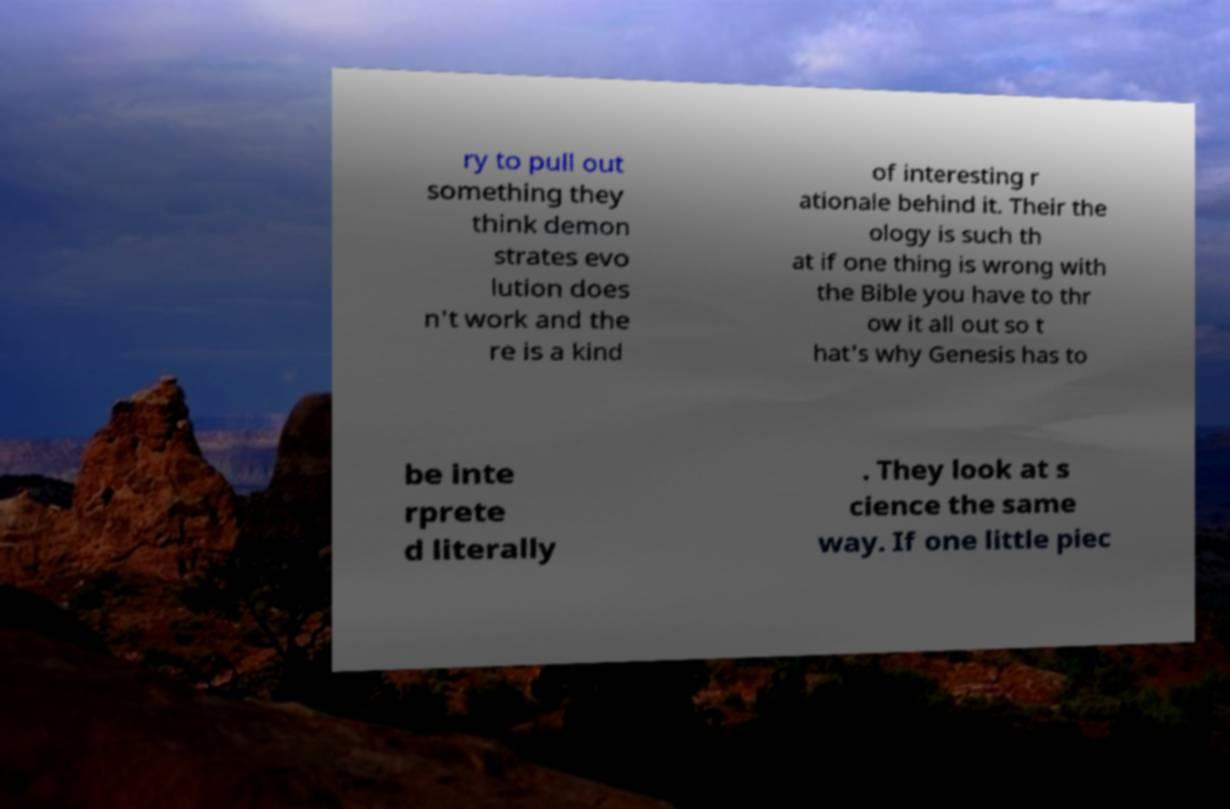What messages or text are displayed in this image? I need them in a readable, typed format. ry to pull out something they think demon strates evo lution does n't work and the re is a kind of interesting r ationale behind it. Their the ology is such th at if one thing is wrong with the Bible you have to thr ow it all out so t hat's why Genesis has to be inte rprete d literally . They look at s cience the same way. If one little piec 